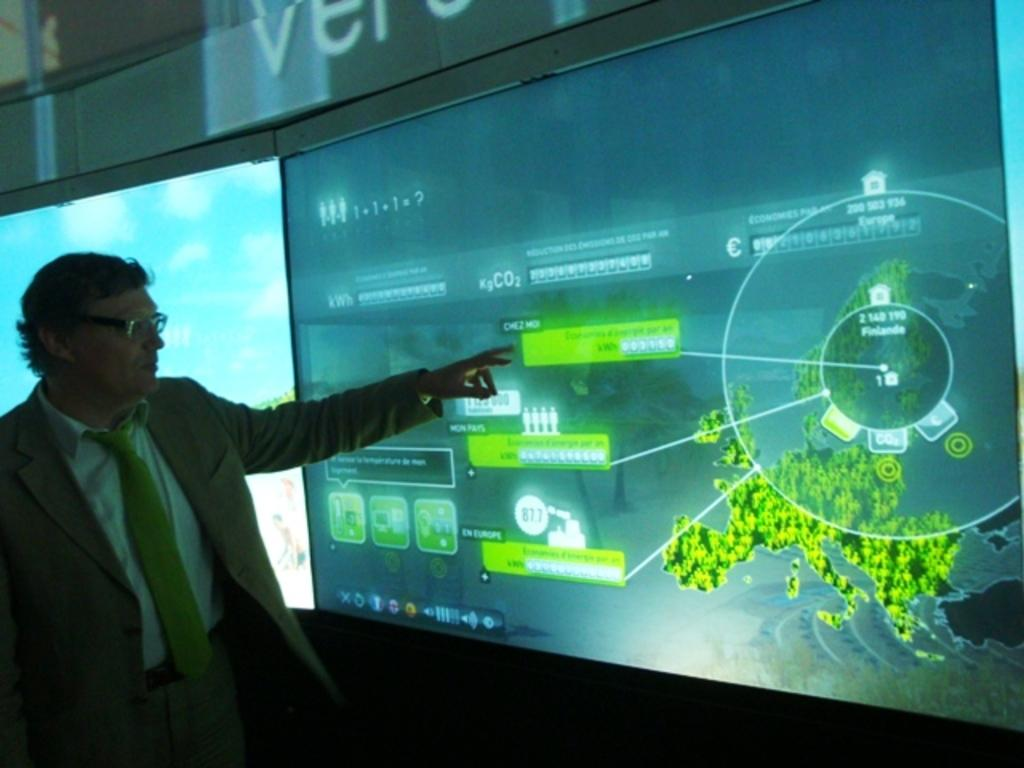<image>
Give a short and clear explanation of the subsequent image. A 1+1+1=? equation is displayed on the top left of the projector screen. 